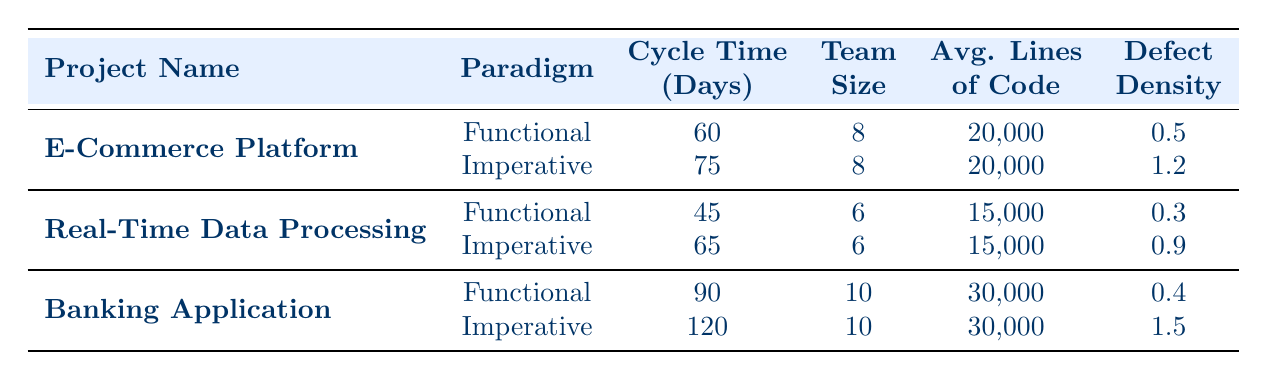What is the development cycle time for the E-Commerce Platform using Functional programming? The table shows that the development cycle time for the E-Commerce Platform using the Functional programming paradigm is 60 days.
Answer: 60 days What is the defect density of the Banking Application when using the Imperative programming paradigm? According to the table, the defect density for the Banking Application using the Imperative programming paradigm is 1.5.
Answer: 1.5 How many more days did it take to develop the Banking Application using Imperative programming compared to Functional programming? The development cycle time for the Banking Application using Imperative programming is 120 days, while it is 90 days using Functional programming. The difference is 120 - 90 = 30 days.
Answer: 30 days What was the average development cycle time for the Functional programming projects listed? The development cycle times for Functional projects are 60, 45, and 90 days. Adding these gives 60 + 45 + 90 = 195 days. There are 3 projects, so the average is 195 / 3 = 65 days.
Answer: 65 days Is the defect density for the Real-Time Data Processing project in Functional programming lower than in Imperative programming? The defect density for Functional programming in the Real-Time Data Processing project is 0.3, while for Imperative programming, it is 0.9. Since 0.3 is less than 0.9, the statement is true.
Answer: Yes Which project had the highest average lines of code, and what was that number? The Banking Application had the highest average lines of code, which is 30,000. The average lines for the other projects are 20,000 for E-Commerce Platform and 15,000 for Real-Time Data Processing.
Answer: 30,000 What is the total development cycle time for the two projects that used Functional programming? The development cycle times for Functional programming are 60 days (E-Commerce Platform), 45 days (Real-Time Data Processing), and 90 days (Banking Application). Adding them gives a total of 60 + 45 + 90 = 195 days.
Answer: 195 days Was the development cycle time for the Imperative version of the Real-Time Data Processing project shorter than that of the E-Commerce Platform? The development cycle time for the Imperative version of Real-Time Data Processing is 65 days while for E-Commerce Platform, it is 75 days. Since 65 days is less than 75 days, the statement is true.
Answer: Yes What was the team size for the projects that used Functional programming? The team sizes for the Functional projects are 8 for E-Commerce Platform, 6 for Real-Time Data Processing, and 10 for Banking Application. The sizes are listed clearly in the table under the corresponding projects.
Answer: 8, 6, 10 